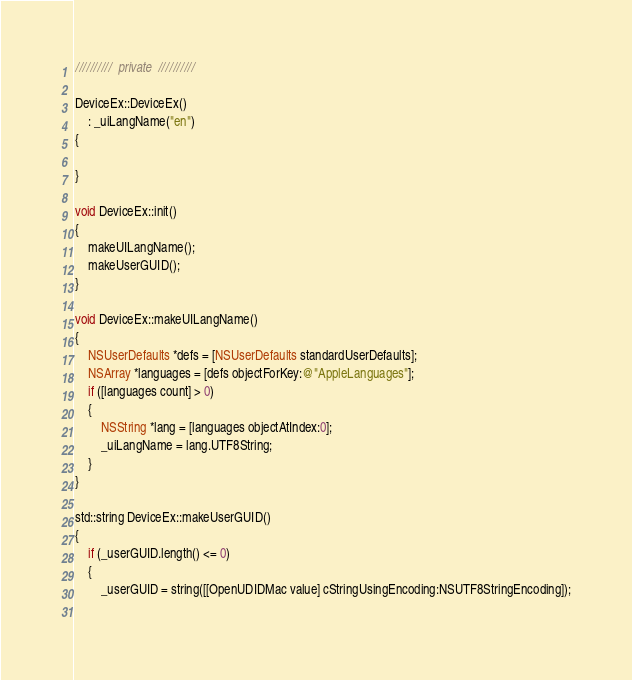Convert code to text. <code><loc_0><loc_0><loc_500><loc_500><_ObjectiveC_>
//////////  private  //////////

DeviceEx::DeviceEx()
    : _uiLangName("en")
{

}

void DeviceEx::init()
{
    makeUILangName();
    makeUserGUID();
}

void DeviceEx::makeUILangName()
{
    NSUserDefaults *defs = [NSUserDefaults standardUserDefaults];
    NSArray *languages = [defs objectForKey:@"AppleLanguages"];
    if ([languages count] > 0)
    {
        NSString *lang = [languages objectAtIndex:0];
        _uiLangName = lang.UTF8String;
    }
}

std::string DeviceEx::makeUserGUID()
{
    if (_userGUID.length() <= 0)
    {
        _userGUID = string([[OpenUDIDMac value] cStringUsingEncoding:NSUTF8StringEncoding]);
        </code> 